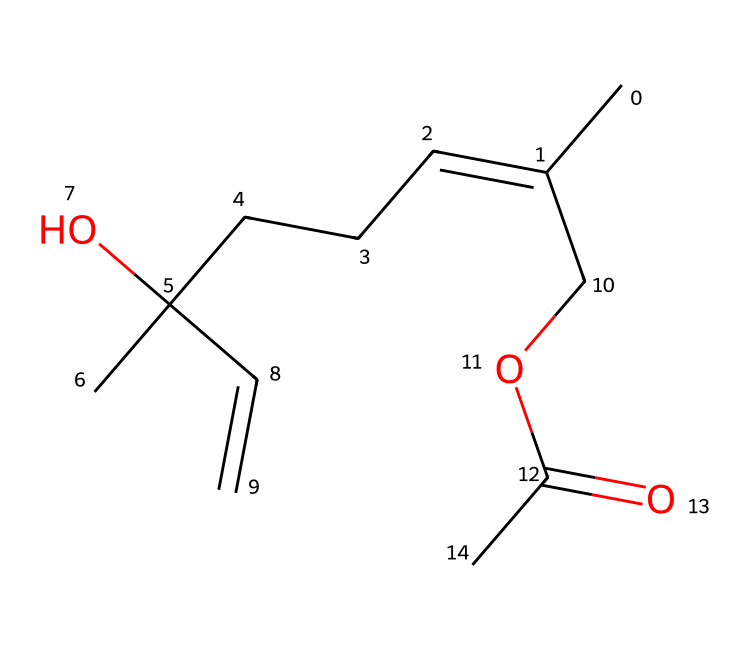How many carbon atoms are in this ester? By analyzing the SMILES representation, we can count the number of 'C' symbols, which indicate carbon atoms. In this case, there are eight carbon atoms present in the structure.
Answer: eight What type of functional group is present in this molecule? In the SMILES representation, the presence of "COC(=O)" indicates an ester functional group, characterized by the carbonyl group (C=O) and an alkoxy group (C-O).
Answer: ester What is the degree of saturation of this ester? The degree of saturation can be assessed by counting the number of double bonds and rings. In this structure, there is one C=C double bond and one carbonyl (C=O) bond, indicating a degree of saturation of about one unsaturation.
Answer: one How many oxygen atoms are present in the chemical structure? The chemical structure contains two occurrences of 'O' in the SMILES, which indicates that there are two oxygen atoms present in this ester molecule.
Answer: two Does this ester contain any hydroxyl groups? The presence of an 'O' connected to a 'C' in the SMILES representation indicates the presence of a hydroxyl group (-OH). In this case, there is one hydroxyl group present in the structure.
Answer: one What is the synthesis method typically used to create esters like this one? Esters are commonly synthesized through a reaction known as esterification, specifically via the reaction of an alcohol and a carboxylic acid. The presence of both components in this SMILES suggests it could represent such a synthesis.
Answer: esterification 